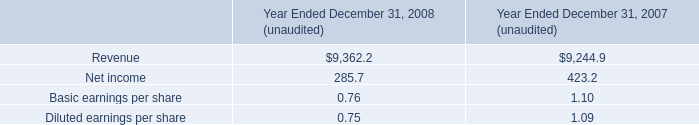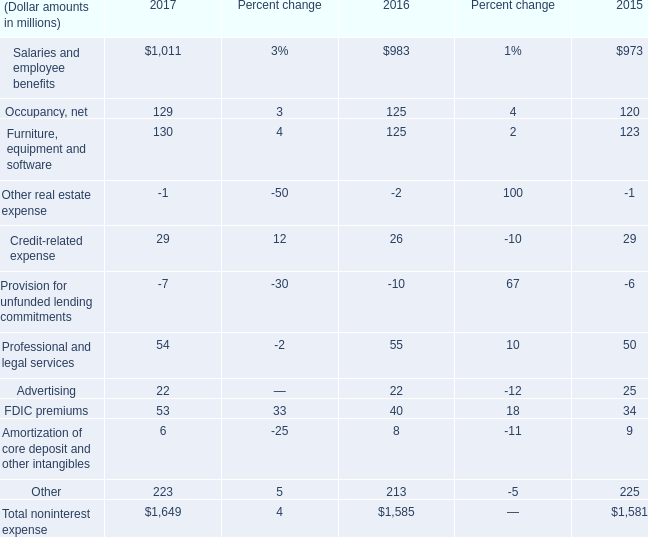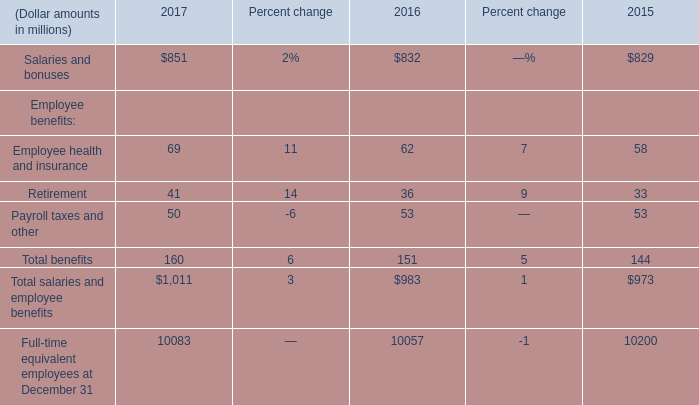In the year with largest amount of Retirement, what's the sum of Employee benefits? (in million) 
Computations: ((69 + 41) + 50)
Answer: 160.0. 